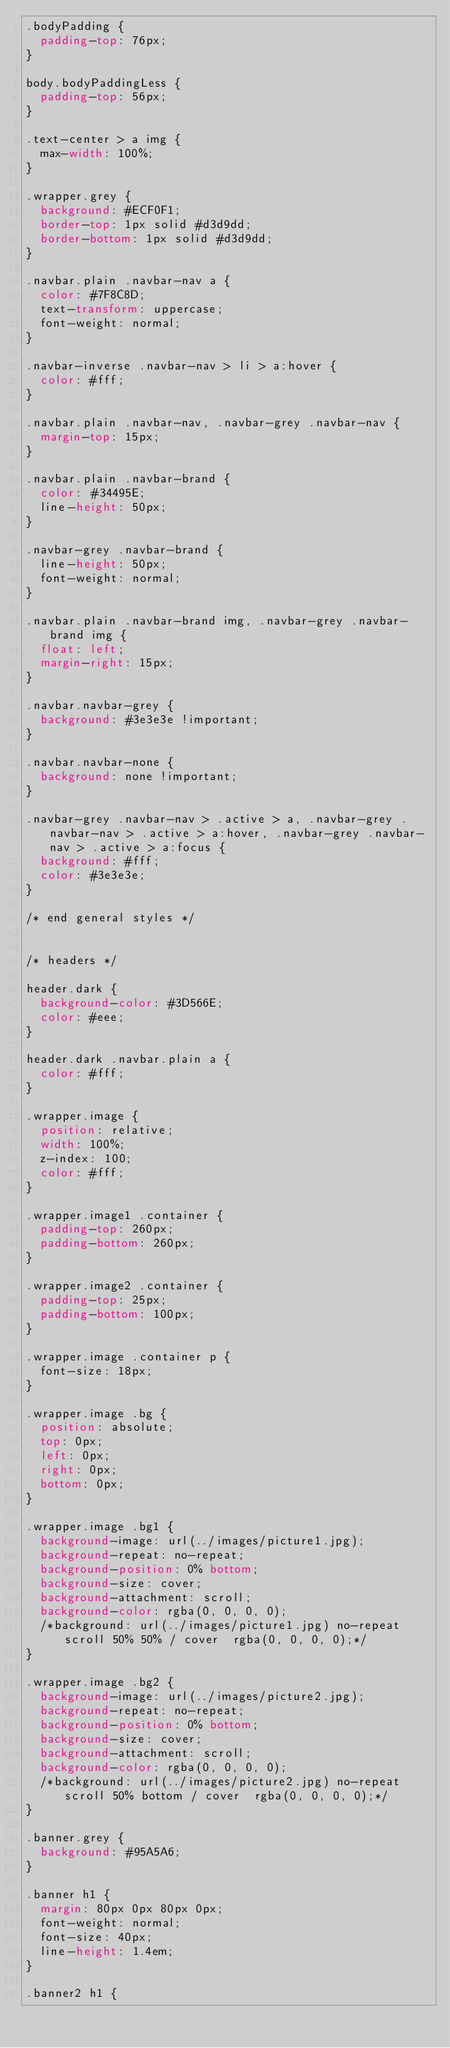<code> <loc_0><loc_0><loc_500><loc_500><_CSS_>.bodyPadding {
	padding-top: 76px;
}

body.bodyPaddingLess {
	padding-top: 56px;
}

.text-center > a img {
	max-width: 100%;
}

.wrapper.grey {
	background: #ECF0F1;
	border-top: 1px solid #d3d9dd;
	border-bottom: 1px solid #d3d9dd;
}

.navbar.plain .navbar-nav a {
	color: #7F8C8D;
	text-transform: uppercase;
	font-weight: normal;
}

.navbar-inverse .navbar-nav > li > a:hover {
	color: #fff;
}

.navbar.plain .navbar-nav, .navbar-grey .navbar-nav {
	margin-top: 15px;
}

.navbar.plain .navbar-brand {
	color: #34495E;
	line-height: 50px;
}

.navbar-grey .navbar-brand {
	line-height: 50px;
	font-weight: normal;
}

.navbar.plain .navbar-brand img, .navbar-grey .navbar-brand img {
	float: left;
	margin-right: 15px;
}

.navbar.navbar-grey {
	background: #3e3e3e !important;
}

.navbar.navbar-none {
	background: none !important;
}

.navbar-grey .navbar-nav > .active > a, .navbar-grey .navbar-nav > .active > a:hover, .navbar-grey .navbar-nav > .active > a:focus {
	background: #fff;
	color: #3e3e3e;
}

/* end general styles */


/* headers */

header.dark {
	background-color: #3D566E;
	color: #eee;
}

header.dark .navbar.plain a {
	color: #fff;
}

.wrapper.image {
	position: relative;
	width: 100%;
	z-index: 100;
	color: #fff;
}

.wrapper.image1 .container {
	padding-top: 260px;
	padding-bottom: 260px;
}

.wrapper.image2 .container {
	padding-top: 25px;
	padding-bottom: 100px;
}

.wrapper.image .container p {
	font-size: 18px;
}

.wrapper.image .bg {
	position: absolute;
	top: 0px;
	left: 0px;
	right: 0px;
	bottom: 0px;
}

.wrapper.image .bg1 {
	background-image: url(../images/picture1.jpg);
	background-repeat: no-repeat;
	background-position: 0% bottom;
	background-size: cover;
	background-attachment: scroll;
	background-color: rgba(0, 0, 0, 0);
	/*background: url(../images/picture1.jpg) no-repeat scroll 50% 50% / cover  rgba(0, 0, 0, 0);*/
}

.wrapper.image .bg2 {
	background-image: url(../images/picture2.jpg);
	background-repeat: no-repeat;
	background-position: 0% bottom;
	background-size: cover;
	background-attachment: scroll;
	background-color: rgba(0, 0, 0, 0);
	/*background: url(../images/picture2.jpg) no-repeat scroll 50% bottom / cover  rgba(0, 0, 0, 0);*/
}

.banner.grey {
	background: #95A5A6;
}

.banner h1 {
	margin: 80px 0px 80px 0px;
	font-weight: normal;
	font-size: 40px;
	line-height: 1.4em;
}

.banner2 h1 {</code> 